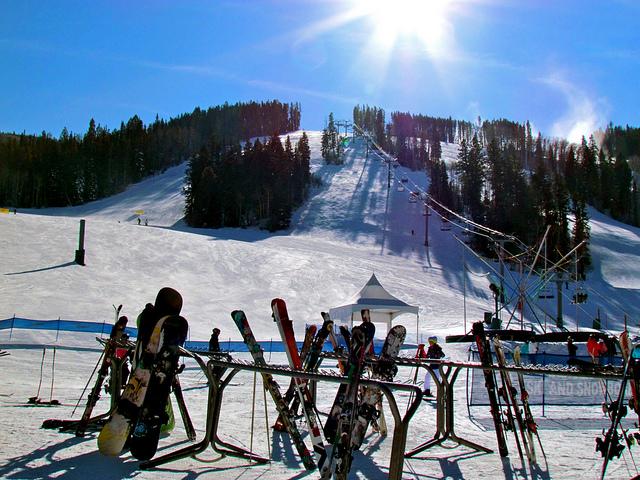What color is that tent?
Quick response, please. White and blue. Is it raining?
Quick response, please. No. Is the sun shining?
Be succinct. Yes. 